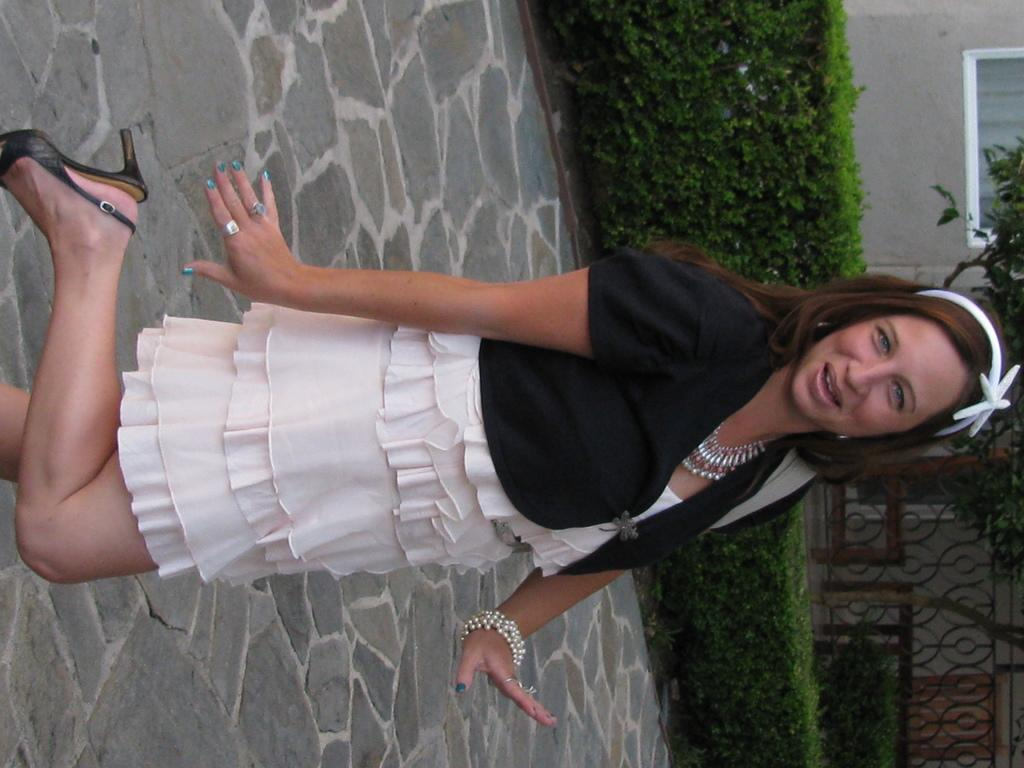What is the woman in the image doing? The woman is standing in the image and smiling. What can be seen behind the woman? There are plants and a tree visible behind the woman. What is in the background of the image? There is a building and a gate in the background of the image. What type of needle is the woman holding in the image? There is no needle present in the image; the woman is simply standing and smiling. 